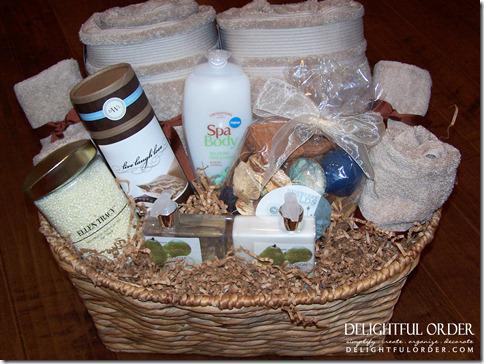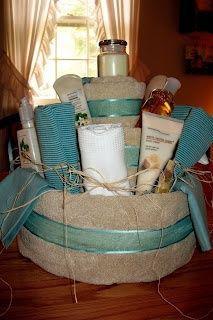The first image is the image on the left, the second image is the image on the right. Evaluate the accuracy of this statement regarding the images: "The towels in the right image are not displayed in a basket-type container.". Is it true? Answer yes or no. No. The first image is the image on the left, the second image is the image on the right. Evaluate the accuracy of this statement regarding the images: "There is a basket in the image on the left.". Is it true? Answer yes or no. Yes. 